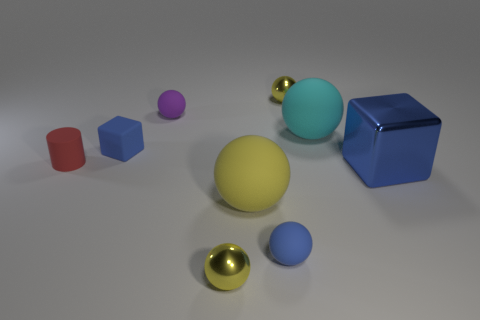Can you tell me the colors of the spheres in the image and their relative sizes? Certainly! In this harmonious arrangement of shapes, we observe spheres of three distinct colors: a primary yellow one that's quite large, a smaller metallic one radiating luxury, and a sizeable one with heavenly hues of blue. The largest of these orbs is the yellow, which sits proudly at the center, followed by the blue with its calming presence, and lastly the metallic one, humbly modest in size. 